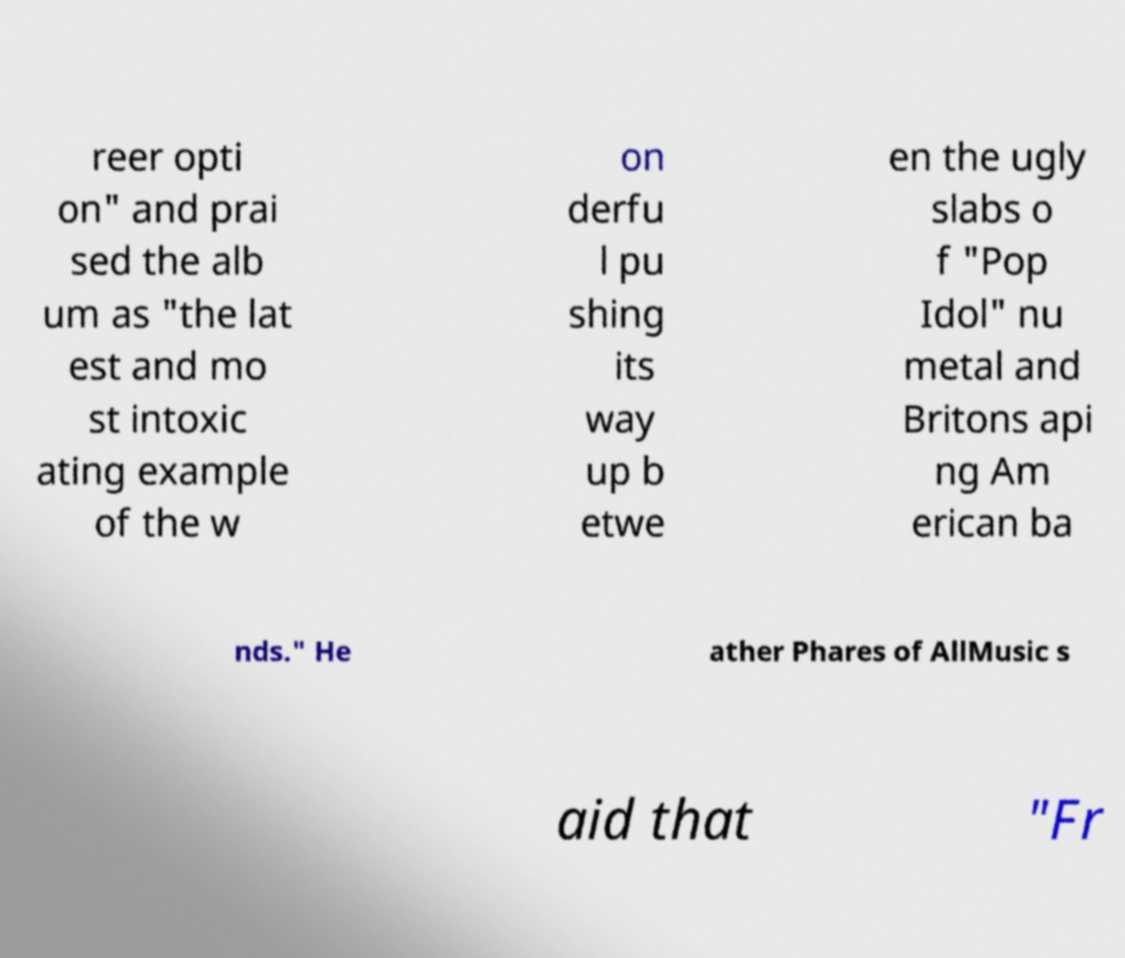For documentation purposes, I need the text within this image transcribed. Could you provide that? reer opti on" and prai sed the alb um as "the lat est and mo st intoxic ating example of the w on derfu l pu shing its way up b etwe en the ugly slabs o f "Pop Idol" nu metal and Britons api ng Am erican ba nds." He ather Phares of AllMusic s aid that "Fr 